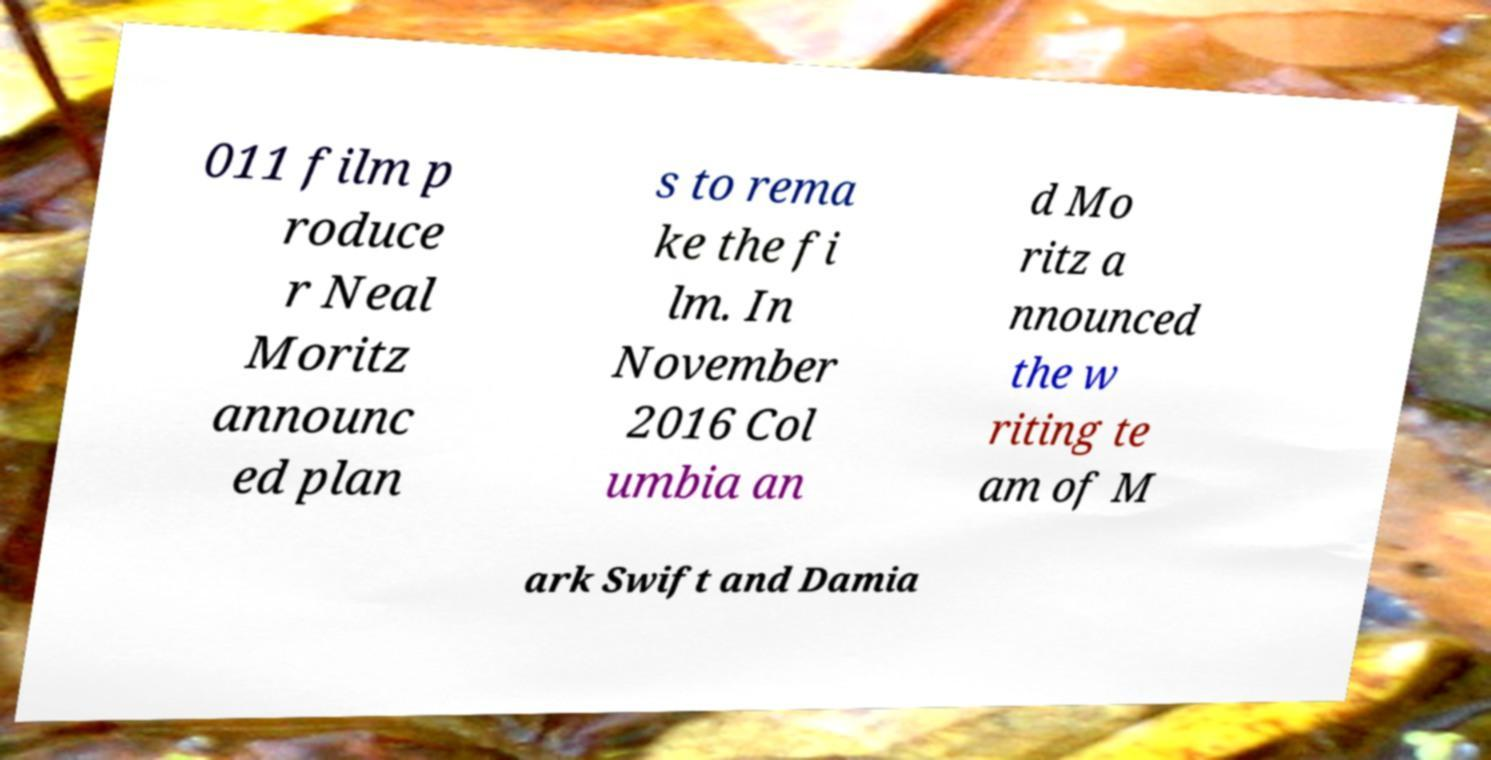There's text embedded in this image that I need extracted. Can you transcribe it verbatim? 011 film p roduce r Neal Moritz announc ed plan s to rema ke the fi lm. In November 2016 Col umbia an d Mo ritz a nnounced the w riting te am of M ark Swift and Damia 